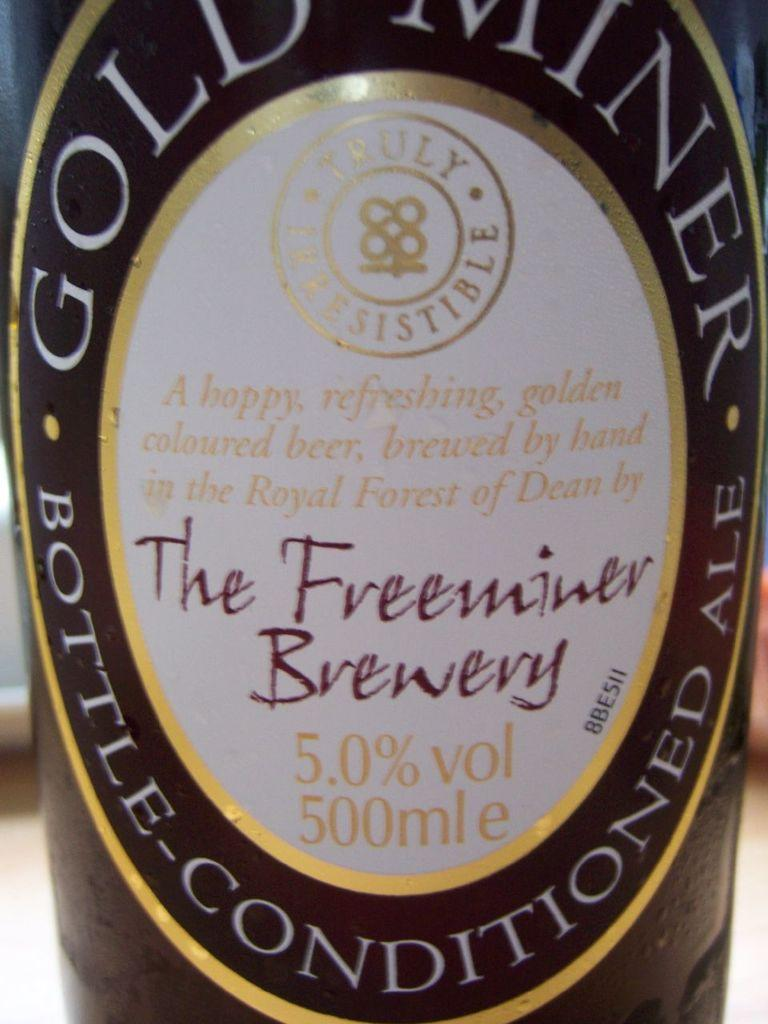<image>
Summarize the visual content of the image. The bottle of conditioned ale from the Freeminer Brewery says it is 5.0% alcohol by volume. 